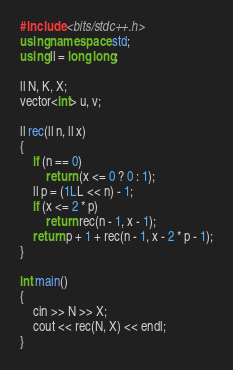<code> <loc_0><loc_0><loc_500><loc_500><_C++_>#include <bits/stdc++.h>
using namespace std;
using ll = long long;

ll N, K, X;
vector<int> u, v;

ll rec(ll n, ll x)
{
    if (n == 0)
        return (x <= 0 ? 0 : 1);
    ll p = (1LL << n) - 1;
    if (x <= 2 * p)
        return rec(n - 1, x - 1);
    return p + 1 + rec(n - 1, x - 2 * p - 1);
}

int main()
{
    cin >> N >> X;
    cout << rec(N, X) << endl;
}</code> 